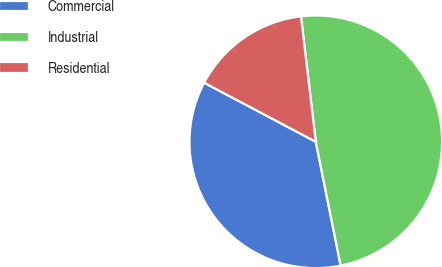Convert chart. <chart><loc_0><loc_0><loc_500><loc_500><pie_chart><fcel>Commercial<fcel>Industrial<fcel>Residential<nl><fcel>35.9%<fcel>48.72%<fcel>15.38%<nl></chart> 